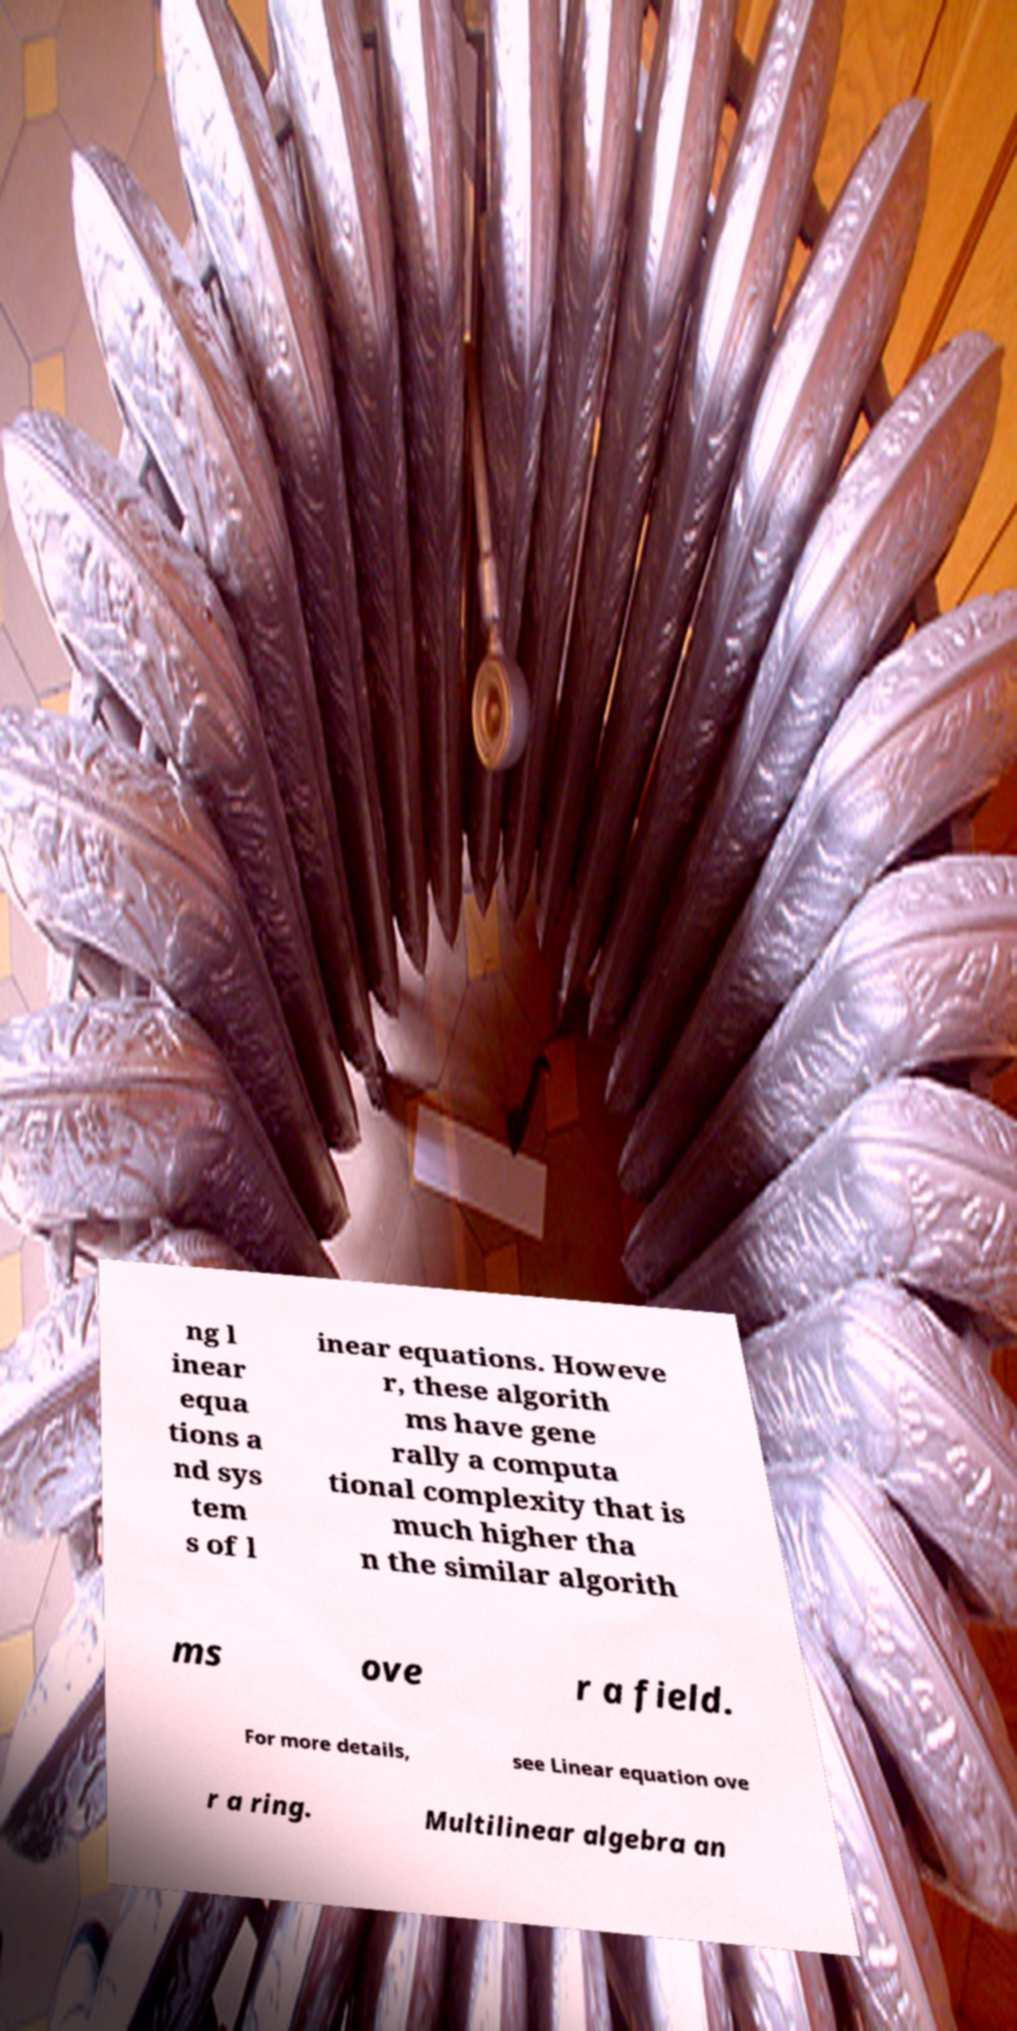Please identify and transcribe the text found in this image. ng l inear equa tions a nd sys tem s of l inear equations. Howeve r, these algorith ms have gene rally a computa tional complexity that is much higher tha n the similar algorith ms ove r a field. For more details, see Linear equation ove r a ring. Multilinear algebra an 